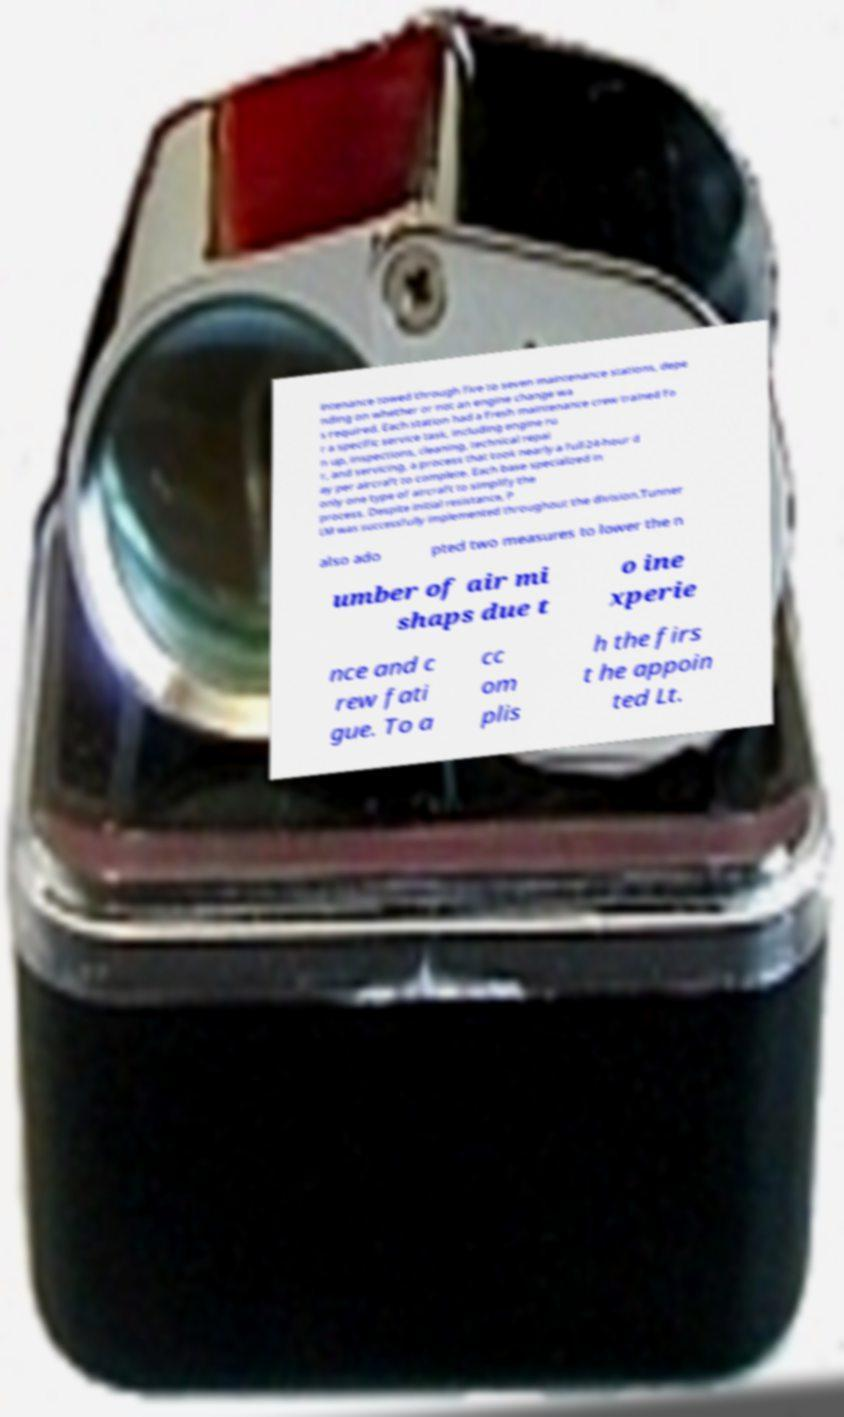Please read and relay the text visible in this image. What does it say? intenance towed through five to seven maintenance stations, depe nding on whether or not an engine change wa s required. Each station had a fresh maintenance crew trained fo r a specific service task, including engine ru n up, inspections, cleaning, technical repai r, and servicing, a process that took nearly a full 24-hour d ay per aircraft to complete. Each base specialized in only one type of aircraft to simplify the process. Despite initial resistance, P LM was successfully implemented throughout the division.Tunner also ado pted two measures to lower the n umber of air mi shaps due t o ine xperie nce and c rew fati gue. To a cc om plis h the firs t he appoin ted Lt. 